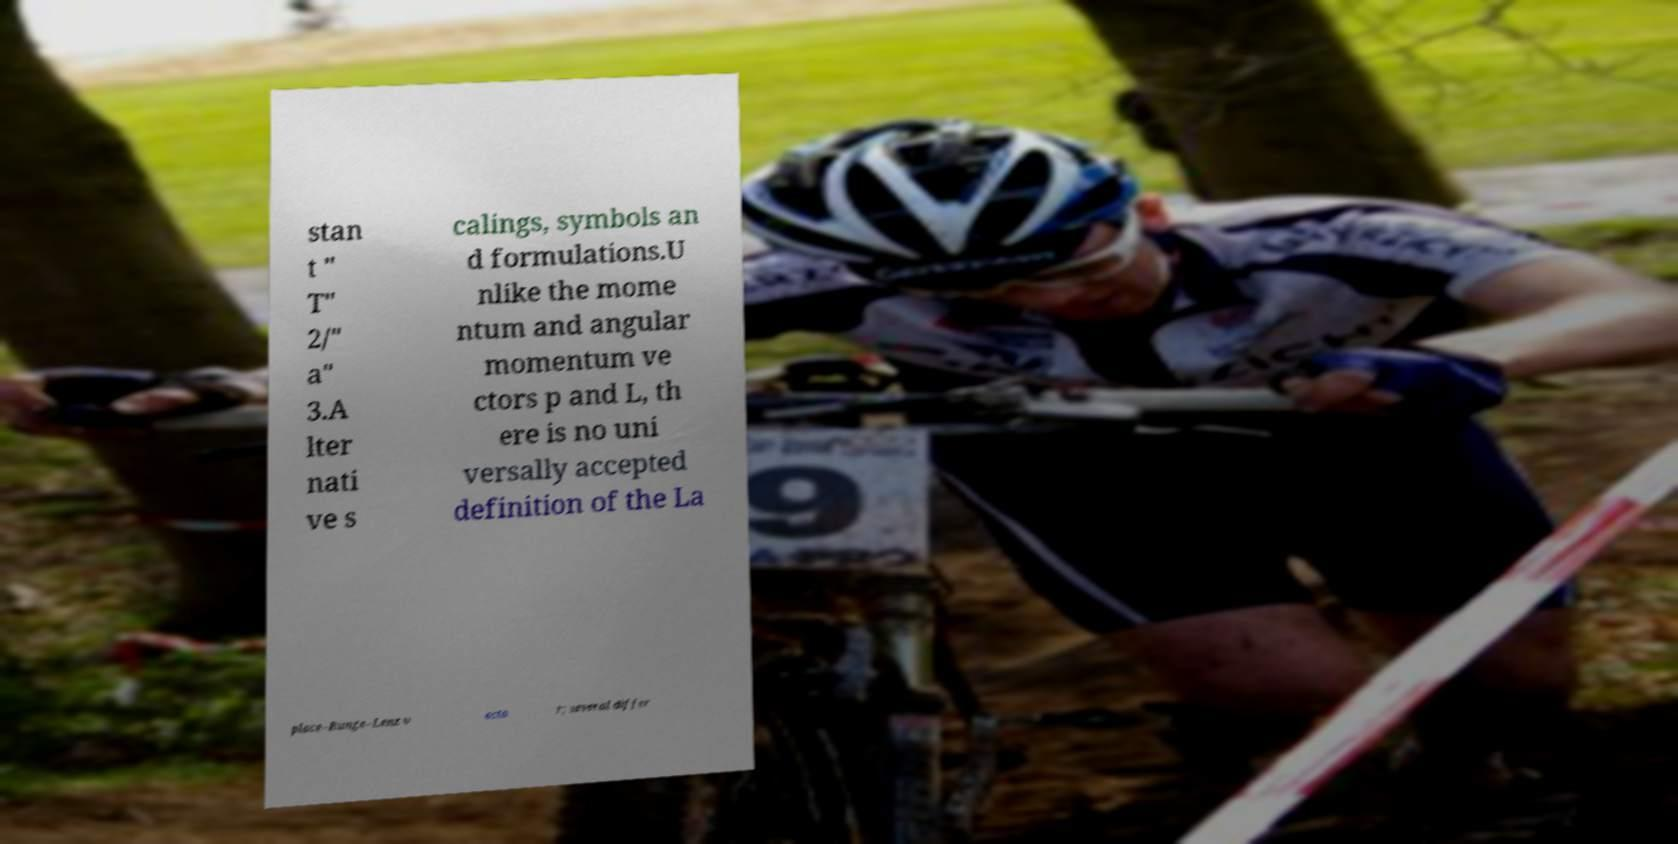I need the written content from this picture converted into text. Can you do that? stan t " T" 2/" a" 3.A lter nati ve s calings, symbols an d formulations.U nlike the mome ntum and angular momentum ve ctors p and L, th ere is no uni versally accepted definition of the La place–Runge–Lenz v ecto r; several differ 